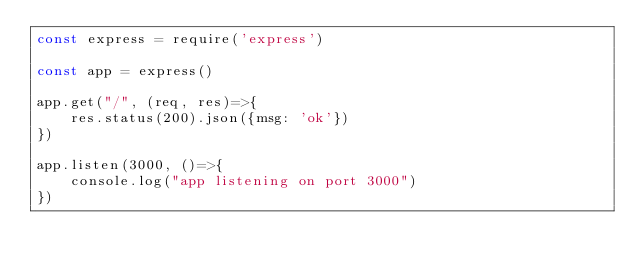<code> <loc_0><loc_0><loc_500><loc_500><_JavaScript_>const express = require('express')

const app = express()

app.get("/", (req, res)=>{
    res.status(200).json({msg: 'ok'})
})

app.listen(3000, ()=>{
    console.log("app listening on port 3000")
})
</code> 